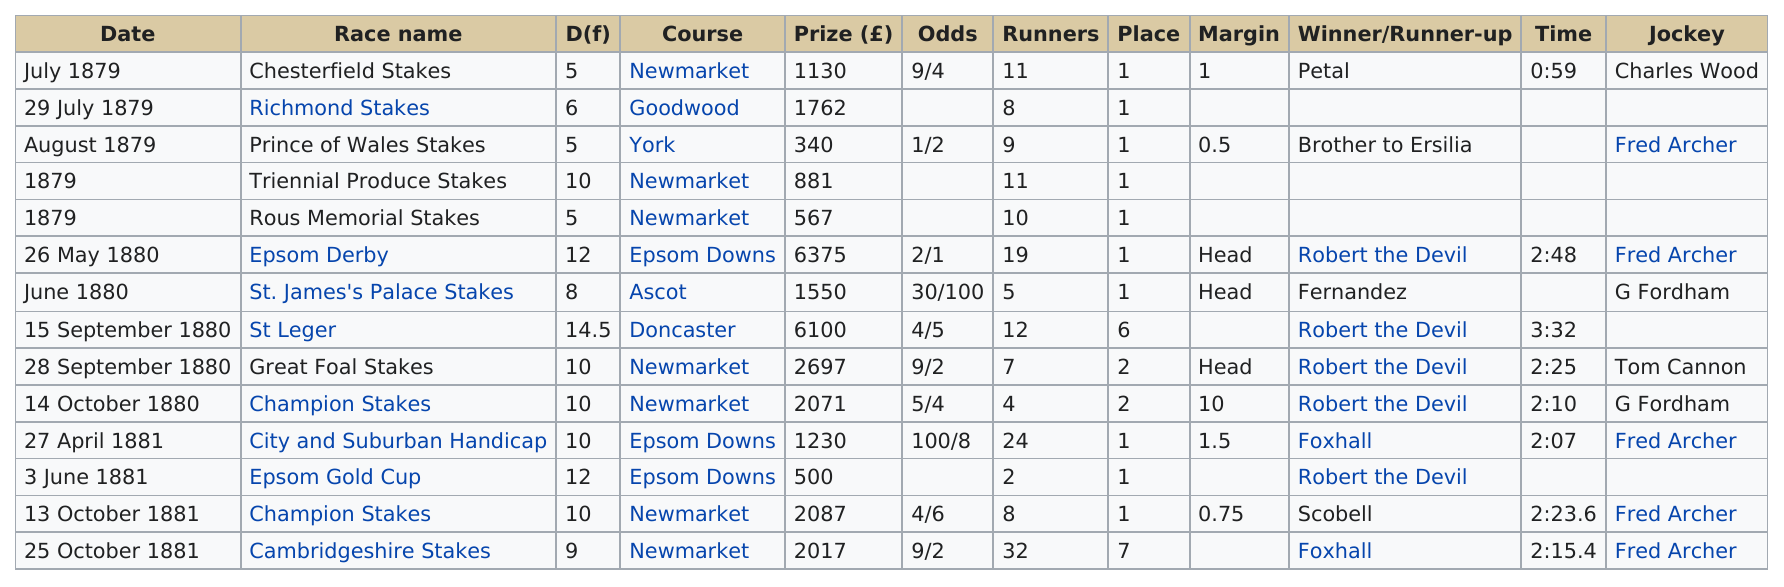Identify some key points in this picture. Bend or Win won his first race in the year 1879. The Epsom Downs racecourse has hosted three races. The first place was won 10 times. The Chesterfield Stakes was the only race won by jockey Charles Wood. In 1880, the race that took the least amount of time to finish was the Champion Stakes. 